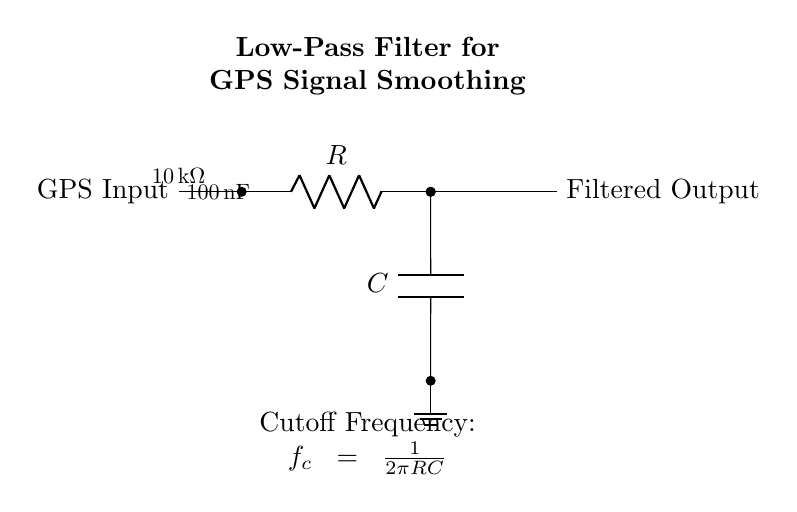What is the resistance value in the circuit? The resistance value is indicated next to the resistor symbol, which shows that it is ten thousand ohms.
Answer: Ten thousand ohms What is the capacitance value used in the filter? The capacitance value is shown next to the capacitor symbol, which indicates it is one hundred nanofarads.
Answer: One hundred nanofarads What is the purpose of the ground connection? The ground connection serves to complete the electrical circuit by providing a reference point for the voltage levels and a return path for current.
Answer: Reference point for voltage What is the cutoff frequency formula given in the circuit? The formula for cutoff frequency is represented as one over two pi times the resistance value times the capacitance value.
Answer: One over two pi RC What type of filter is represented by this circuit? The circuit diagram clearly indicates that it is a low-pass filter designed to allow low-frequency signals and attenuate high-frequency noise.
Answer: Low-pass filter How does the low-pass filter affect GPS signal inputs? The low-pass filter smooths out rapid fluctuations in the GPS signal, allowing for a cleaner output signal that enhances navigation accuracy.
Answer: Smooths fluctuations 